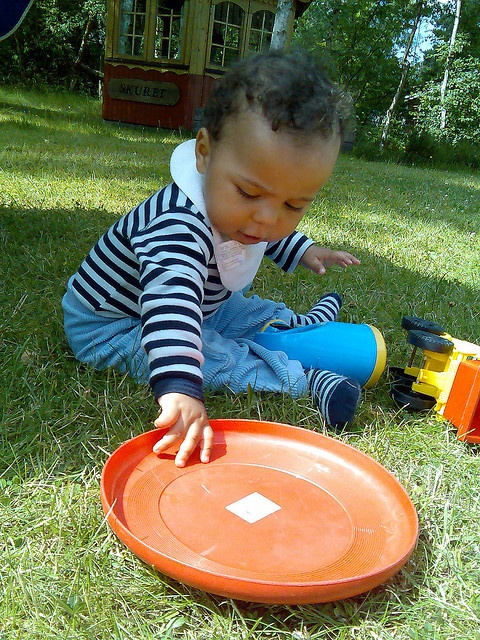Describe the objects in this image and their specific colors. I can see people in black, gray, lightblue, and navy tones and frisbee in black, tan, salmon, and white tones in this image. 